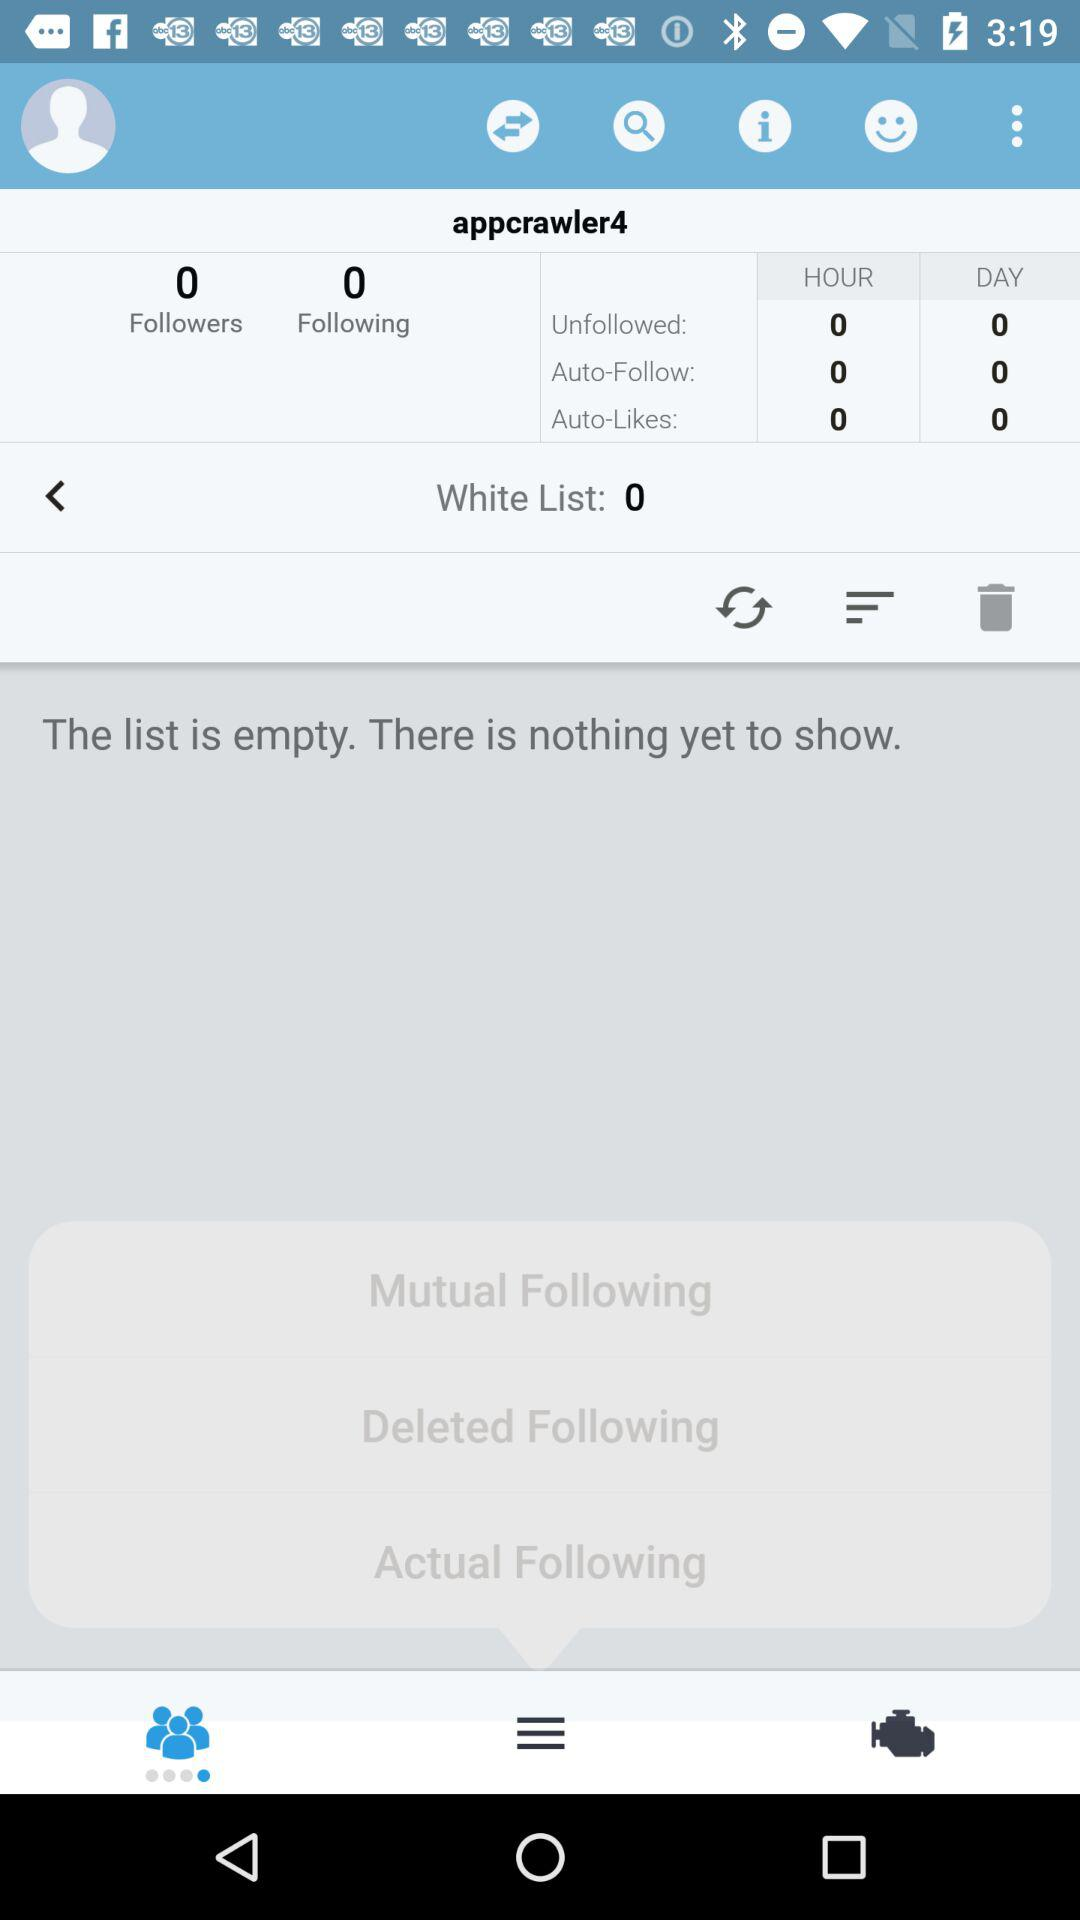How many people are there in the "Following"? There are zero people. 